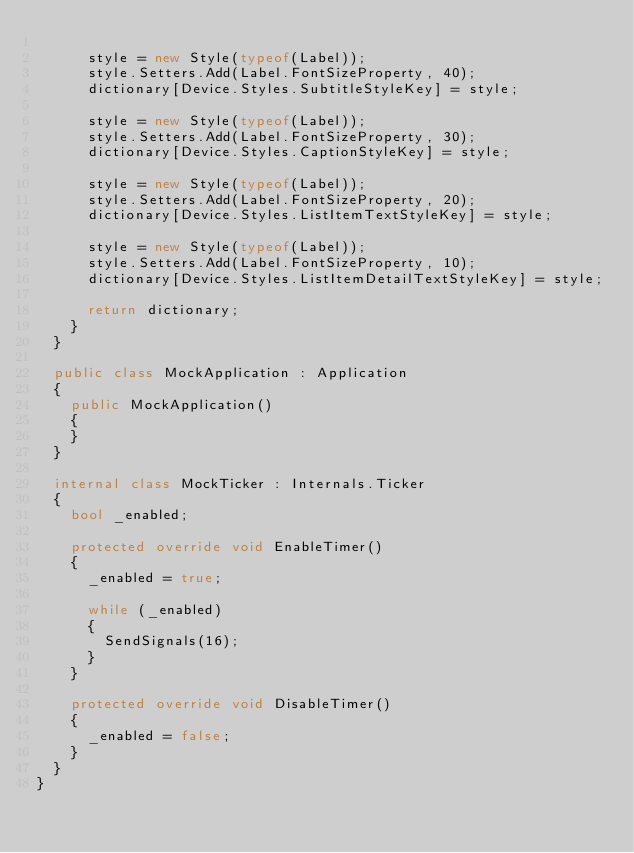Convert code to text. <code><loc_0><loc_0><loc_500><loc_500><_C#_>
			style = new Style(typeof(Label));
			style.Setters.Add(Label.FontSizeProperty, 40);
			dictionary[Device.Styles.SubtitleStyleKey] = style;

			style = new Style(typeof(Label));
			style.Setters.Add(Label.FontSizeProperty, 30);
			dictionary[Device.Styles.CaptionStyleKey] = style;

			style = new Style(typeof(Label));
			style.Setters.Add(Label.FontSizeProperty, 20);
			dictionary[Device.Styles.ListItemTextStyleKey] = style;

			style = new Style(typeof(Label));
			style.Setters.Add(Label.FontSizeProperty, 10);
			dictionary[Device.Styles.ListItemDetailTextStyleKey] = style;

			return dictionary;
		}
	}

	public class MockApplication : Application
	{
		public MockApplication()
		{
		}
	}

	internal class MockTicker : Internals.Ticker
	{
		bool _enabled;

		protected override void EnableTimer()
		{
			_enabled = true;

			while (_enabled)
			{
				SendSignals(16);
			}
		}

		protected override void DisableTimer()
		{
			_enabled = false;
		}
	}
}</code> 